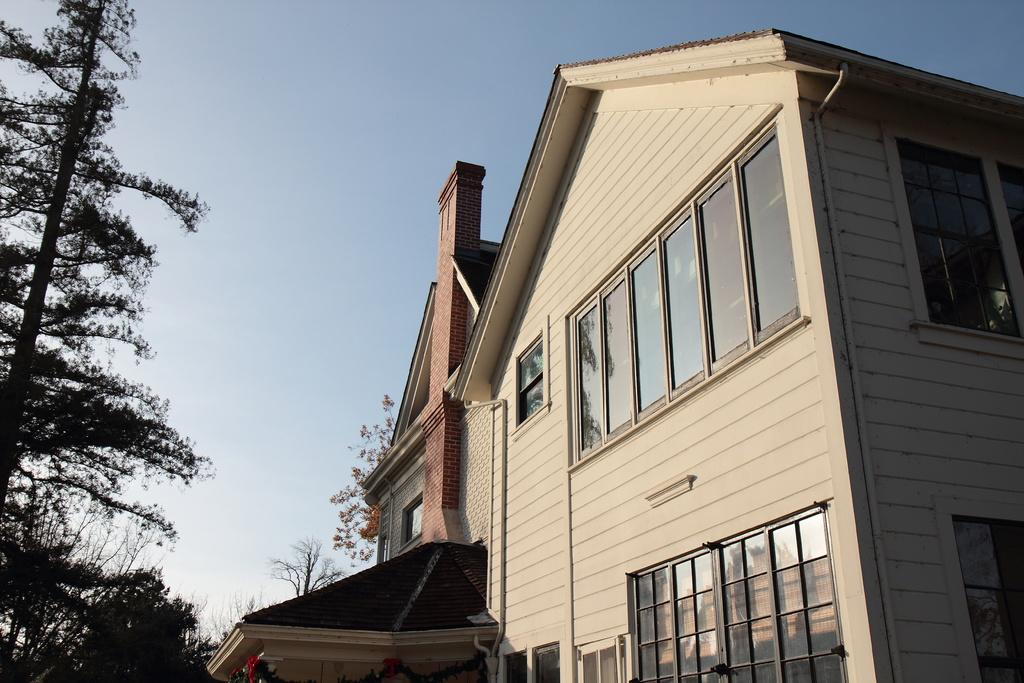What type of structure is visible in the picture? There is a building with windows in the picture. What other elements can be seen in the picture? There are trees in the picture. What can be seen in the background of the picture? The sky is visible in the background of the picture. What color is the crayon being used by the group in the picture? There is no group or crayon present in the picture; it features a building, trees, and the sky. 